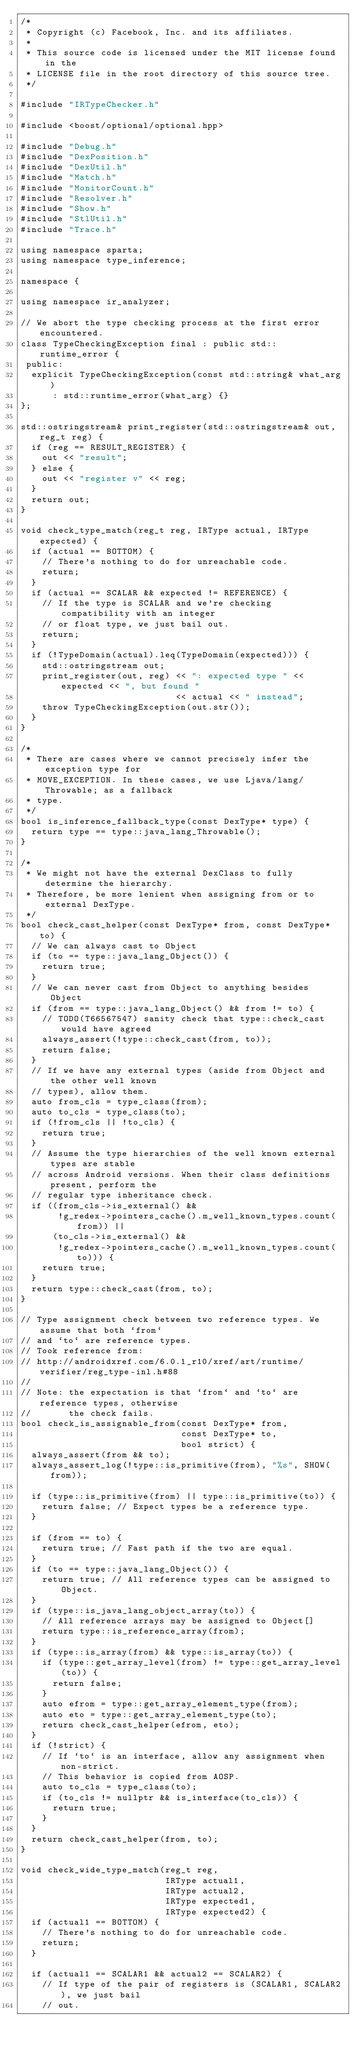Convert code to text. <code><loc_0><loc_0><loc_500><loc_500><_C++_>/*
 * Copyright (c) Facebook, Inc. and its affiliates.
 *
 * This source code is licensed under the MIT license found in the
 * LICENSE file in the root directory of this source tree.
 */

#include "IRTypeChecker.h"

#include <boost/optional/optional.hpp>

#include "Debug.h"
#include "DexPosition.h"
#include "DexUtil.h"
#include "Match.h"
#include "MonitorCount.h"
#include "Resolver.h"
#include "Show.h"
#include "StlUtil.h"
#include "Trace.h"

using namespace sparta;
using namespace type_inference;

namespace {

using namespace ir_analyzer;

// We abort the type checking process at the first error encountered.
class TypeCheckingException final : public std::runtime_error {
 public:
  explicit TypeCheckingException(const std::string& what_arg)
      : std::runtime_error(what_arg) {}
};

std::ostringstream& print_register(std::ostringstream& out, reg_t reg) {
  if (reg == RESULT_REGISTER) {
    out << "result";
  } else {
    out << "register v" << reg;
  }
  return out;
}

void check_type_match(reg_t reg, IRType actual, IRType expected) {
  if (actual == BOTTOM) {
    // There's nothing to do for unreachable code.
    return;
  }
  if (actual == SCALAR && expected != REFERENCE) {
    // If the type is SCALAR and we're checking compatibility with an integer
    // or float type, we just bail out.
    return;
  }
  if (!TypeDomain(actual).leq(TypeDomain(expected))) {
    std::ostringstream out;
    print_register(out, reg) << ": expected type " << expected << ", but found "
                             << actual << " instead";
    throw TypeCheckingException(out.str());
  }
}

/*
 * There are cases where we cannot precisely infer the exception type for
 * MOVE_EXCEPTION. In these cases, we use Ljava/lang/Throwable; as a fallback
 * type.
 */
bool is_inference_fallback_type(const DexType* type) {
  return type == type::java_lang_Throwable();
}

/*
 * We might not have the external DexClass to fully determine the hierarchy.
 * Therefore, be more lenient when assigning from or to external DexType.
 */
bool check_cast_helper(const DexType* from, const DexType* to) {
  // We can always cast to Object
  if (to == type::java_lang_Object()) {
    return true;
  }
  // We can never cast from Object to anything besides Object
  if (from == type::java_lang_Object() && from != to) {
    // TODO(T66567547) sanity check that type::check_cast would have agreed
    always_assert(!type::check_cast(from, to));
    return false;
  }
  // If we have any external types (aside from Object and the other well known
  // types), allow them.
  auto from_cls = type_class(from);
  auto to_cls = type_class(to);
  if (!from_cls || !to_cls) {
    return true;
  }
  // Assume the type hierarchies of the well known external types are stable
  // across Android versions. When their class definitions present, perform the
  // regular type inheritance check.
  if ((from_cls->is_external() &&
       !g_redex->pointers_cache().m_well_known_types.count(from)) ||
      (to_cls->is_external() &&
       !g_redex->pointers_cache().m_well_known_types.count(to))) {
    return true;
  }
  return type::check_cast(from, to);
}

// Type assignment check between two reference types. We assume that both `from`
// and `to` are reference types.
// Took reference from:
// http://androidxref.com/6.0.1_r10/xref/art/runtime/verifier/reg_type-inl.h#88
//
// Note: the expectation is that `from` and `to` are reference types, otherwise
//       the check fails.
bool check_is_assignable_from(const DexType* from,
                              const DexType* to,
                              bool strict) {
  always_assert(from && to);
  always_assert_log(!type::is_primitive(from), "%s", SHOW(from));

  if (type::is_primitive(from) || type::is_primitive(to)) {
    return false; // Expect types be a reference type.
  }

  if (from == to) {
    return true; // Fast path if the two are equal.
  }
  if (to == type::java_lang_Object()) {
    return true; // All reference types can be assigned to Object.
  }
  if (type::is_java_lang_object_array(to)) {
    // All reference arrays may be assigned to Object[]
    return type::is_reference_array(from);
  }
  if (type::is_array(from) && type::is_array(to)) {
    if (type::get_array_level(from) != type::get_array_level(to)) {
      return false;
    }
    auto efrom = type::get_array_element_type(from);
    auto eto = type::get_array_element_type(to);
    return check_cast_helper(efrom, eto);
  }
  if (!strict) {
    // If `to` is an interface, allow any assignment when non-strict.
    // This behavior is copied from AOSP.
    auto to_cls = type_class(to);
    if (to_cls != nullptr && is_interface(to_cls)) {
      return true;
    }
  }
  return check_cast_helper(from, to);
}

void check_wide_type_match(reg_t reg,
                           IRType actual1,
                           IRType actual2,
                           IRType expected1,
                           IRType expected2) {
  if (actual1 == BOTTOM) {
    // There's nothing to do for unreachable code.
    return;
  }

  if (actual1 == SCALAR1 && actual2 == SCALAR2) {
    // If type of the pair of registers is (SCALAR1, SCALAR2), we just bail
    // out.</code> 